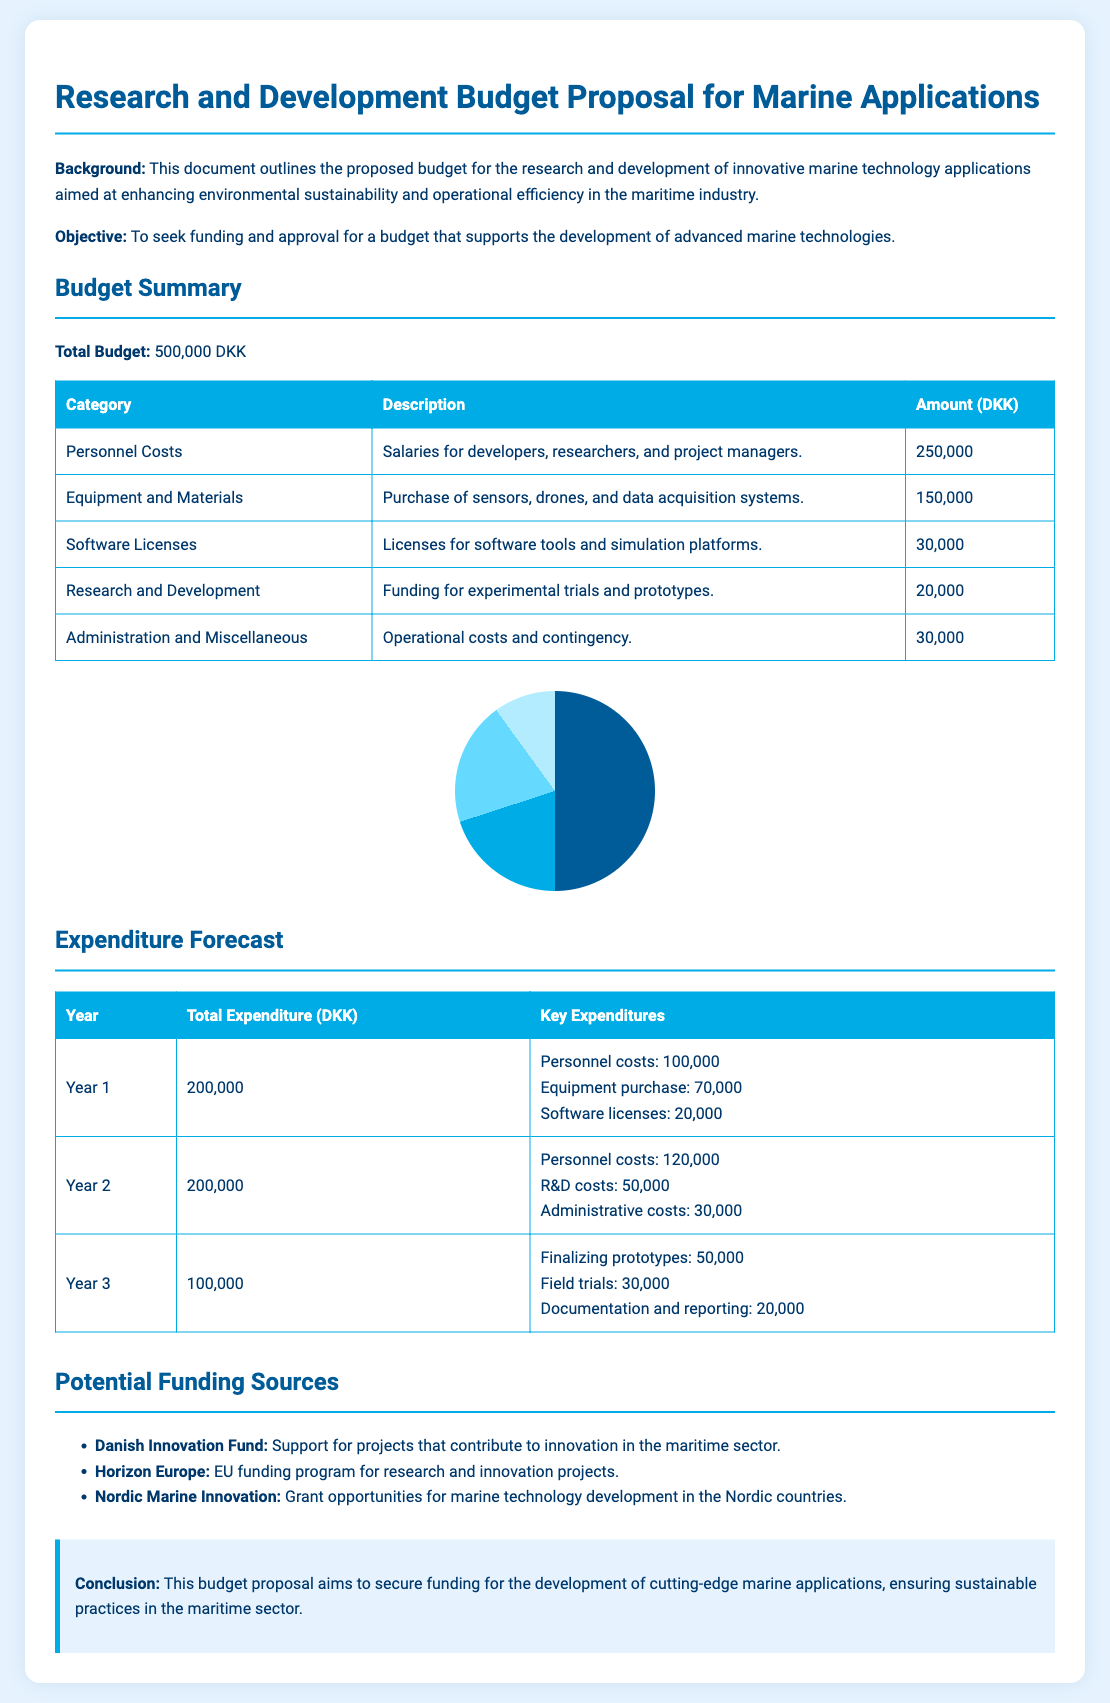what is the total budget? The total budget is explicitly stated in the document as 500,000 DKK.
Answer: 500,000 DKK how much is allocated for Personnel Costs? Personnel costs are detailed in the budget summary, allocated as 250,000 DKK.
Answer: 250,000 DKK which organization supports projects in the maritime sector? The document mentions the Danish Innovation Fund as a supporter for such projects.
Answer: Danish Innovation Fund what is the expenditure for Year 2? The total expenditure for Year 2 is provided in the expenditure forecast section.
Answer: 200,000 DKK how much is allocated for Equipment and Materials? The budget summary lists Equipment and Materials amounting to 150,000 DKK.
Answer: 150,000 DKK what is the purpose of this proposal? The objective of the proposal is stated as seeking funding and approval for advanced marine technologies.
Answer: Seeking funding and approval how many years does the expenditure forecast cover? The expenditure forecast details funding requirements for three years.
Answer: Three years what is the amount for Software Licenses? In the budget summary, the amount specified for Software Licenses is 30,000 DKK.
Answer: 30,000 DKK which EU program is mentioned for research funding? The document lists Horizon Europe as an EU funding program for research and innovation projects.
Answer: Horizon Europe 